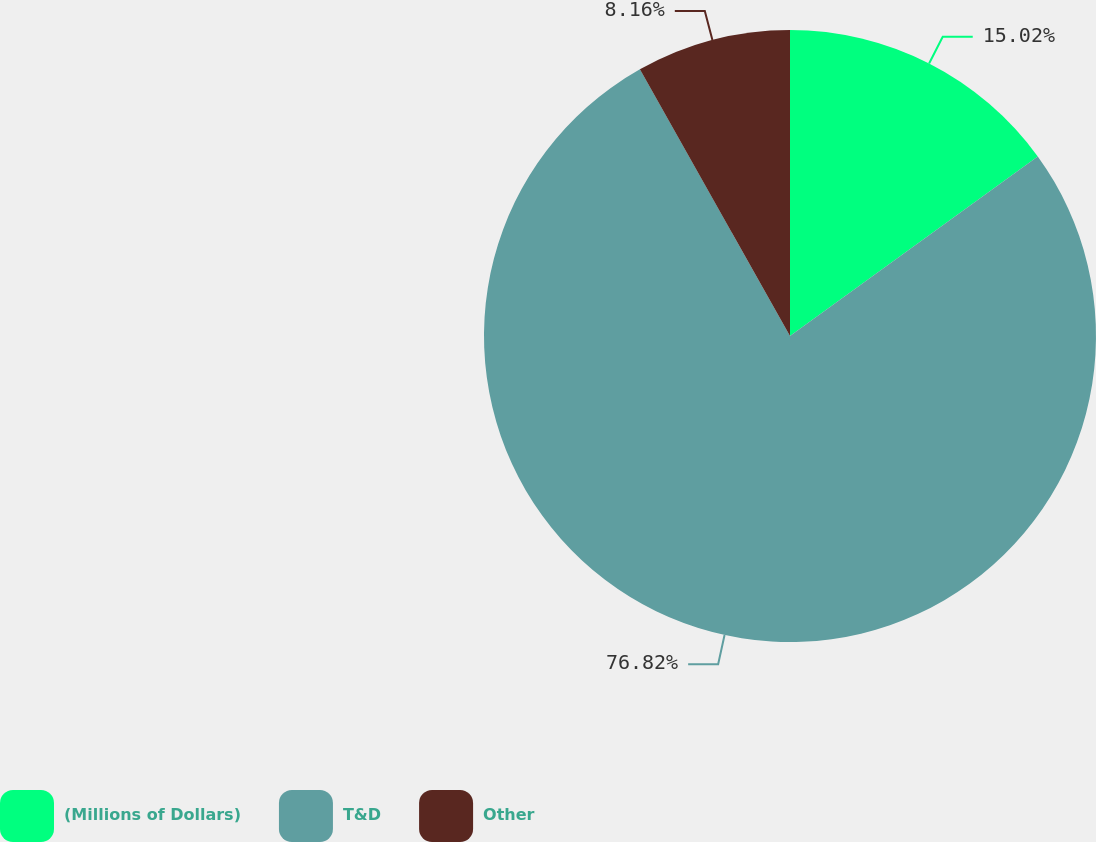Convert chart. <chart><loc_0><loc_0><loc_500><loc_500><pie_chart><fcel>(Millions of Dollars)<fcel>T&D<fcel>Other<nl><fcel>15.02%<fcel>76.82%<fcel>8.16%<nl></chart> 